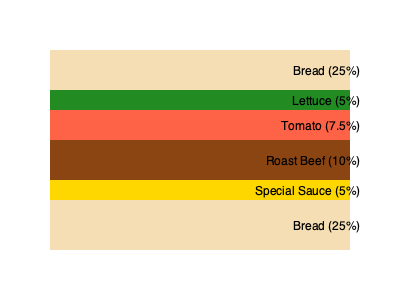Based on the cross-section diagram of your signature roast beef sandwich, calculate the ratio of protein to vegetables. If you were to increase the vegetable content to match the protein, how much would you need to add as a percentage of the total sandwich? To solve this problem, let's follow these steps:

1. Identify the protein and vegetable components:
   Protein: Roast Beef (10%)
   Vegetables: Lettuce (5%) + Tomato (7.5%) = 12.5%

2. Calculate the current ratio of protein to vegetables:
   Ratio = Protein / Vegetables = 10% / 12.5% = 4/5 = 0.8

3. To make the vegetable content match the protein:
   - Current vegetable content: 12.5%
   - Target vegetable content: 10% (to match protein)
   - Difference: 10% - 12.5% = -2.5%

4. Calculate the percentage increase needed:
   Increase needed = |Difference| / Total sandwich content
   = 2.5% / 100% = 0.025 or 2.5%

Therefore, you would need to add 2.5% more vegetables to make the vegetable content match the protein content.
Answer: 2.5% 